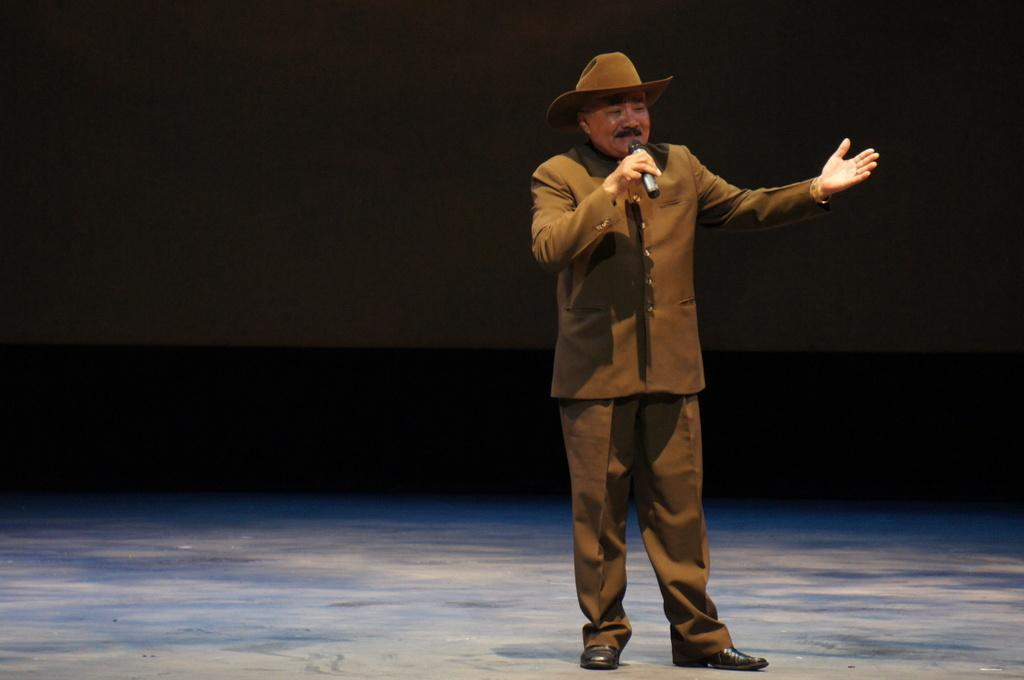What is the main subject of the image? There is a person standing in the image. What is the person wearing? The person is wearing a brown dress. What is the person holding in the image? The person is holding a microphone. Can you describe the background of the image? The background of the image is dark. Are there any toys visible in the image? No, there are no toys present in the image. Can you see a kitten playing with an umbrella in the image? No, there is no kitten or umbrella present in the image. 